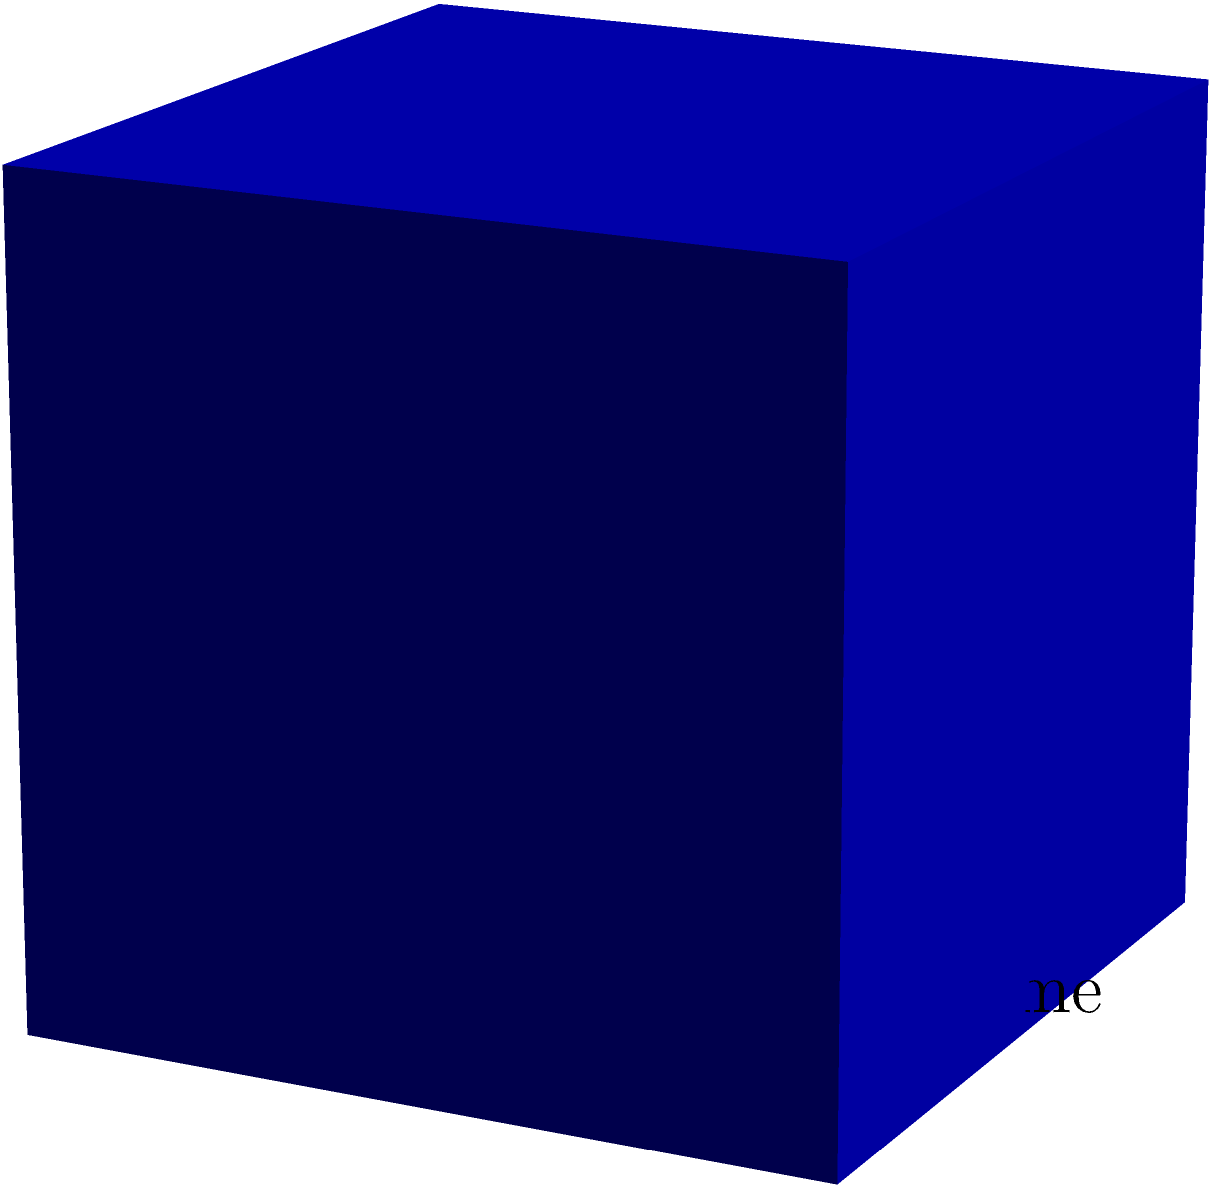A cube is used to illustrate compound interest growth over time. The edge length of the cube represents the principal amount invested, which is $10,000. If the annual interest rate is 8% compounded annually, and the surface area of the cube after 3 years represents the total amount, what is the total amount after 3 years? Round your answer to the nearest dollar. Let's approach this step-by-step:

1) The formula for compound interest is:
   $A = P(1 + r)^t$
   Where:
   $A$ = Final amount
   $P$ = Principal amount
   $r$ = Annual interest rate (as a decimal)
   $t$ = Time in years

2) We're given:
   $P = 10,000$
   $r = 0.08$ (8% as a decimal)
   $t = 3$ years

3) Let's calculate the final amount:
   $A = 10,000(1 + 0.08)^3$
   $A = 10,000(1.08)^3$
   $A = 10,000 * 1.259712$
   $A = 12,597.12$

4) Now, this amount represents the volume of the new cube. We need to find the edge length of this cube to calculate its surface area.

5) The edge length of the new cube will be:
   $a = \sqrt[3]{12,597.12} = 23.2831$

6) The surface area of a cube is given by $6a^2$, where $a$ is the edge length.

7) Surface Area $= 6 * 23.2831^2 = 3,254.76$

8) This surface area represents our final amount. Rounding to the nearest dollar gives us $3,255.

Therefore, the total amount after 3 years, represented by the surface area of the new cube, is $3,255.
Answer: $3,255 